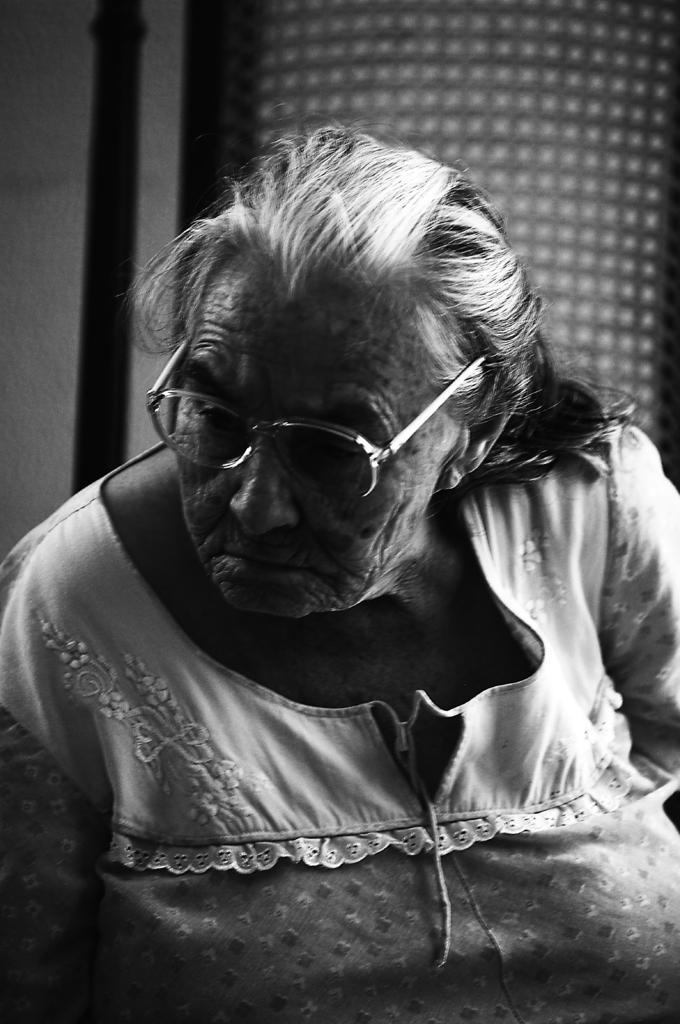In one or two sentences, can you explain what this image depicts? In this image I can see a woman in the front and I can see she is wearing a specs. I can also see this image is black and white in colour. 